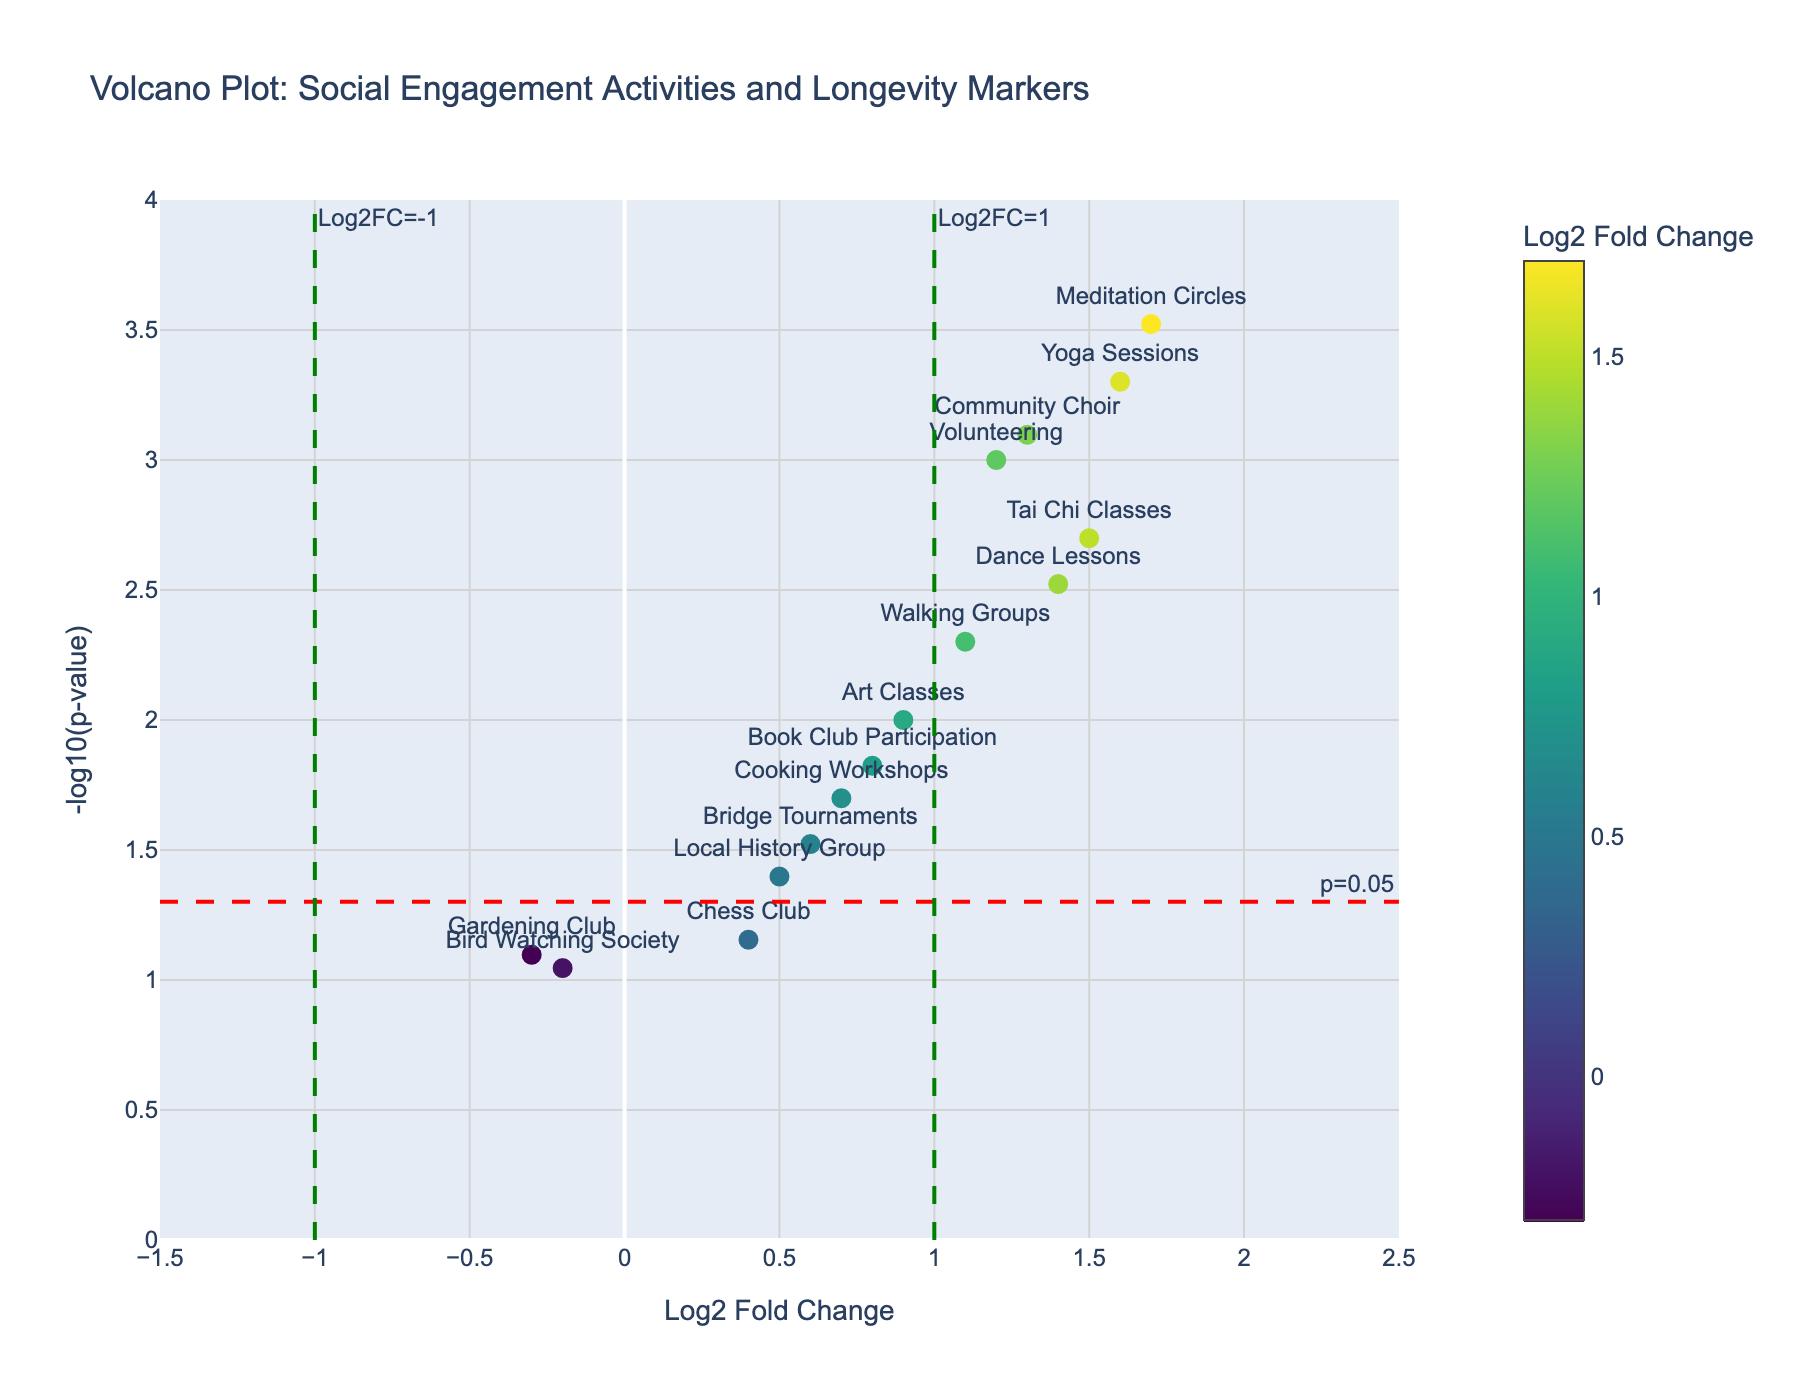What's the title of the figure? The title of the figure is displayed at the top of the plot. It reads "Volcano Plot: Social Engagement Activities and Longevity Markers."
Answer: Volcano Plot: Social Engagement Activities and Longevity Markers What is the y-axis label? The label on the y-axis is located at the left side of the plot. It reads "-log10(p-value)."
Answer: -log10(p-value) Which activity has the highest -log10(p-value)? The highest -log10(p-value) can be identified by finding the topmost point on the plot. The activity corresponding to the highest point is "Meditation Circles."
Answer: Meditation Circles How many activities are above the threshold of p=0.05? The threshold line for p=0.05 is represented by a red, dashed horizontal line. Count the number of points above this line. Nine points are above this line.
Answer: 9 Which activities have a Log2 Fold Change greater than 1? Activities with a Log2 Fold Change greater than 1 are located to the right of the vertical green dashed line at Log2FC=1. These activities are "Volunteering," "Tai Chi Classes," "Community Choir," "Dance Lessons," "Yoga Sessions," and "Meditation Circles."
Answer: Volunteering, Tai Chi Classes, Community Choir, Dance Lessons, Yoga Sessions, Meditation Circles Which activity has the lowest p-value and what is its Log2 Fold Change? The activity with the lowest p-value would have the highest -log10(p-value). This is "Meditation Circles," and its Log2 Fold Change can be found directly below the point on the x-axis, which is 1.7.
Answer: Meditation Circles, 1.7 Compare the -log10(p-value) of "Volunteering" and "Local History Group." Which one is higher and by how much? Find the -log10(p-value) for both activities. "Volunteering" is higher as its -log10(p-value) is 3 (-log10(0.001)) and "Local History Group" is 1.4 (-log10(0.04)). The difference is 3 - 1.4 = 1.6.
Answer: Volunteering, 1.6 Are there any activities with a Log2 Fold Change of less than -0.2? Points left of the vertical green dashed line at Log2FC=-0.2 represent activities with Log2 Fold Change less than -0.2. These activities are "Gardening Club" and "Bird Watching Society."
Answer: Gardening Club, Bird Watching Society How many activities have both statistically significant p-values (less than 0.05) and a positive Log2 Fold Change? Statistically significant p-values are those with -log10(p-value) above the red dashed line (p=0.05). Positive Log2 Fold Change means points to the right of Log2FC=0. Count the points meeting both criteria. There are eight such points.
Answer: 8 